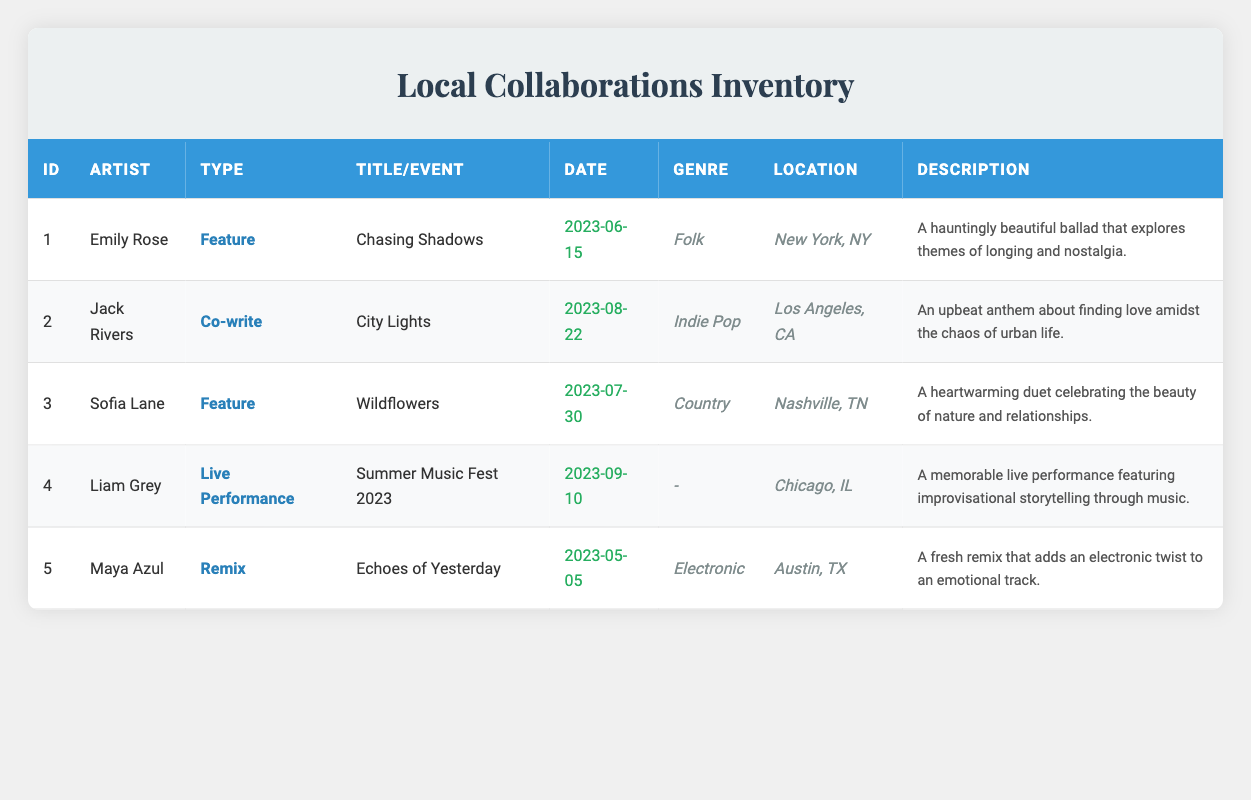What artist collaborated on a feature song released on June 15, 2023? According to the table, the artist who collaborated on a feature song released on June 15, 2023, is Emily Rose with the song title "Chasing Shadows."
Answer: Emily Rose How many collaborations of type "Feature" are listed in the table? In the table, there are three collaborations that have the type "Feature." These are with Emily Rose ("Chasing Shadows"), Sofia Lane ("Wildflowers"), and also counting Liam Grey's "Live Performance" which is not a feature but might be confused if not careful. Thus, only Emily Rose and Sofia Lane count as features.
Answer: 2 Is there a collaboration between local musicians from Nashville? There is a collaboration from Nashville, which is with Sofia Lane on the song "Wildflowers." The table shows that this collaboration is of type "Feature."
Answer: Yes What is the genre of the song "City Lights"? The table lists the genre of "City Lights," which is a collaboration with Jack Rivers, as "Indie Pop."
Answer: Indie Pop Which collaboration has the latest release date? In the table, the latest release date is for the collaboration with Jack Rivers for the song "City Lights," released on August 22, 2023. Thus, it is the most recent collaboration.
Answer: City Lights What is the average number of collaborations per collaboration type listed in the table? There are five collaborations in total and four distinct types (Feature, Co-write, Live Performance, and Remix). The average number of collaborations per type is calculated as follows: 5 collaborations / 4 types = 1.25 collaborations per type.
Answer: 1.25 What city hosted the live performance featuring Liam Grey? The table indicates that the live performance featuring Liam Grey took place in Chicago, IL, during the event "Summer Music Fest 2023."
Answer: Chicago, IL Do all collaborations mentioned in the table have a song title? Yes, except for the live performance which is listed as a Type "Live Performance," does not have a song title listed. This indicates that not all collaborations have a specific song title attached to them.
Answer: No 